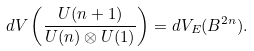Convert formula to latex. <formula><loc_0><loc_0><loc_500><loc_500>d V \left ( \frac { U ( n + 1 ) } { U ( n ) \otimes U ( 1 ) } \right ) = d V _ { E } ( B ^ { 2 n } ) .</formula> 